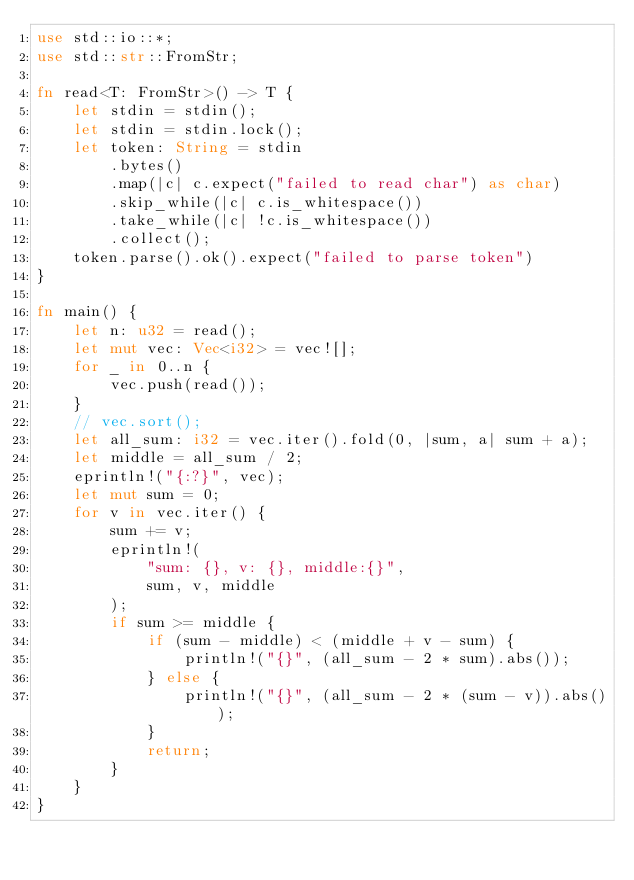Convert code to text. <code><loc_0><loc_0><loc_500><loc_500><_Rust_>use std::io::*;
use std::str::FromStr;

fn read<T: FromStr>() -> T {
    let stdin = stdin();
    let stdin = stdin.lock();
    let token: String = stdin
        .bytes()
        .map(|c| c.expect("failed to read char") as char)
        .skip_while(|c| c.is_whitespace())
        .take_while(|c| !c.is_whitespace())
        .collect();
    token.parse().ok().expect("failed to parse token")
}

fn main() {
    let n: u32 = read();
    let mut vec: Vec<i32> = vec![];
    for _ in 0..n {
        vec.push(read());
    }
    // vec.sort();
    let all_sum: i32 = vec.iter().fold(0, |sum, a| sum + a);
    let middle = all_sum / 2;
    eprintln!("{:?}", vec);
    let mut sum = 0;
    for v in vec.iter() {
        sum += v;
        eprintln!(
            "sum: {}, v: {}, middle:{}",
            sum, v, middle
        );
        if sum >= middle {
            if (sum - middle) < (middle + v - sum) {
                println!("{}", (all_sum - 2 * sum).abs());
            } else {
                println!("{}", (all_sum - 2 * (sum - v)).abs());
            }
            return;
        }
    }
}
</code> 